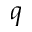<formula> <loc_0><loc_0><loc_500><loc_500>q</formula> 